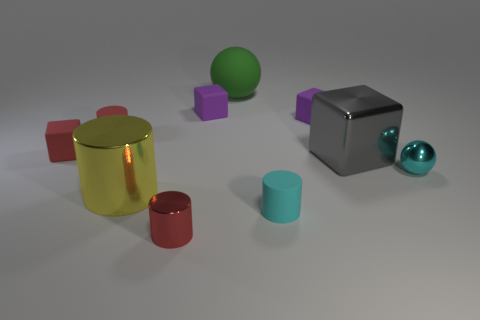Subtract 1 cylinders. How many cylinders are left? 3 Subtract all cylinders. How many objects are left? 6 Subtract all purple matte balls. Subtract all tiny red metal things. How many objects are left? 9 Add 1 green matte balls. How many green matte balls are left? 2 Add 10 big purple shiny blocks. How many big purple shiny blocks exist? 10 Subtract 1 gray cubes. How many objects are left? 9 